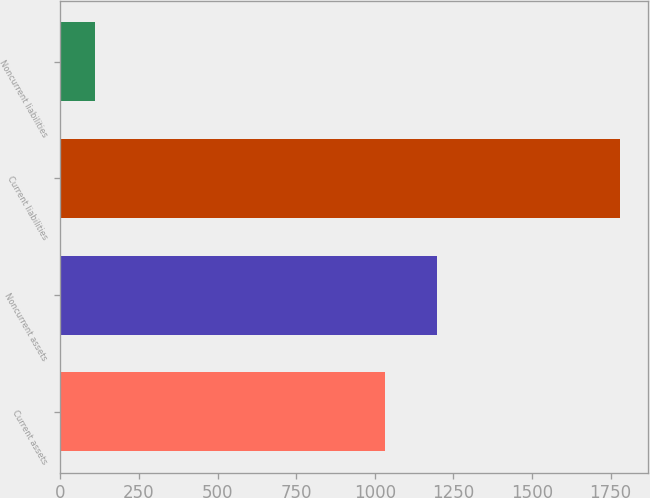Convert chart to OTSL. <chart><loc_0><loc_0><loc_500><loc_500><bar_chart><fcel>Current assets<fcel>Noncurrent assets<fcel>Current liabilities<fcel>Noncurrent liabilities<nl><fcel>1031.1<fcel>1197.97<fcel>1779<fcel>110.3<nl></chart> 